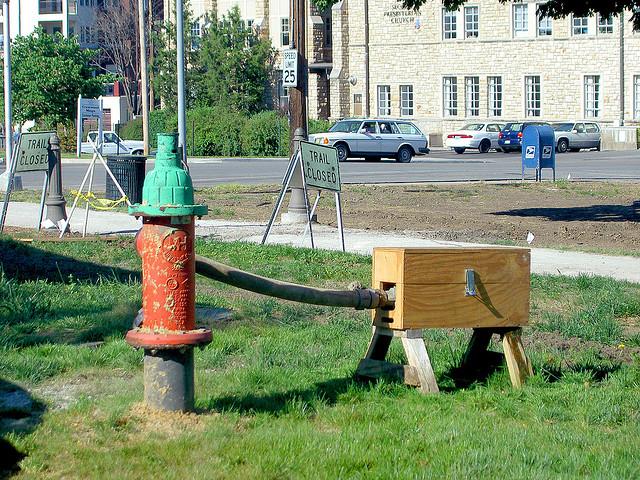What do the signs say in this picture?
Be succinct. Trail closed. What color is the top of the fire hydrant?
Answer briefly. Green. How many cars are there?
Short answer required. 5. 